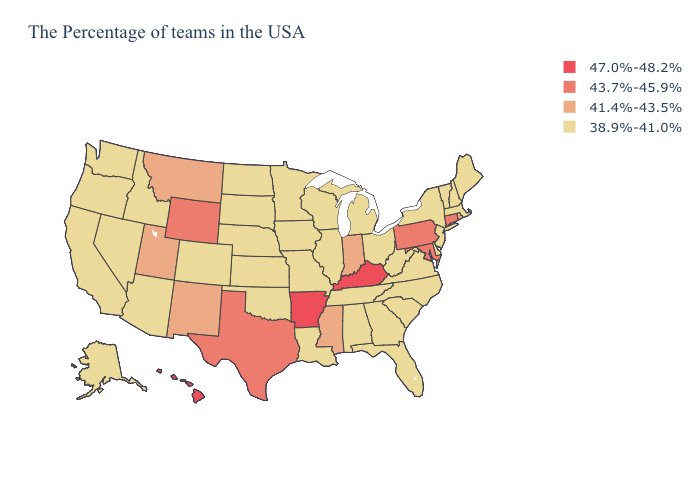What is the highest value in states that border Indiana?
Short answer required. 47.0%-48.2%. What is the highest value in the USA?
Write a very short answer. 47.0%-48.2%. Among the states that border Kansas , which have the lowest value?
Keep it brief. Missouri, Nebraska, Oklahoma, Colorado. What is the lowest value in states that border Ohio?
Be succinct. 38.9%-41.0%. Name the states that have a value in the range 47.0%-48.2%?
Short answer required. Kentucky, Arkansas, Hawaii. Name the states that have a value in the range 47.0%-48.2%?
Quick response, please. Kentucky, Arkansas, Hawaii. What is the value of Oregon?
Keep it brief. 38.9%-41.0%. Which states have the highest value in the USA?
Give a very brief answer. Kentucky, Arkansas, Hawaii. Does the map have missing data?
Concise answer only. No. Which states have the lowest value in the USA?
Keep it brief. Maine, Massachusetts, New Hampshire, Vermont, New York, New Jersey, Delaware, Virginia, North Carolina, South Carolina, West Virginia, Ohio, Florida, Georgia, Michigan, Alabama, Tennessee, Wisconsin, Illinois, Louisiana, Missouri, Minnesota, Iowa, Kansas, Nebraska, Oklahoma, South Dakota, North Dakota, Colorado, Arizona, Idaho, Nevada, California, Washington, Oregon, Alaska. Among the states that border Idaho , which have the highest value?
Give a very brief answer. Wyoming. Which states have the lowest value in the USA?
Short answer required. Maine, Massachusetts, New Hampshire, Vermont, New York, New Jersey, Delaware, Virginia, North Carolina, South Carolina, West Virginia, Ohio, Florida, Georgia, Michigan, Alabama, Tennessee, Wisconsin, Illinois, Louisiana, Missouri, Minnesota, Iowa, Kansas, Nebraska, Oklahoma, South Dakota, North Dakota, Colorado, Arizona, Idaho, Nevada, California, Washington, Oregon, Alaska. What is the value of Arizona?
Answer briefly. 38.9%-41.0%. Does Kansas have a higher value than Indiana?
Be succinct. No. 